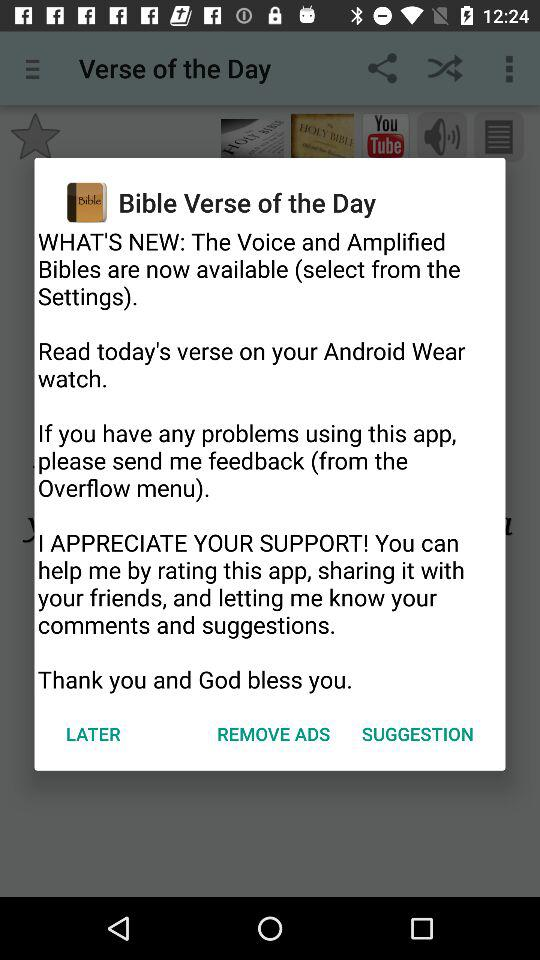What is the verse of the day?
When the provided information is insufficient, respond with <no answer>. <no answer> 